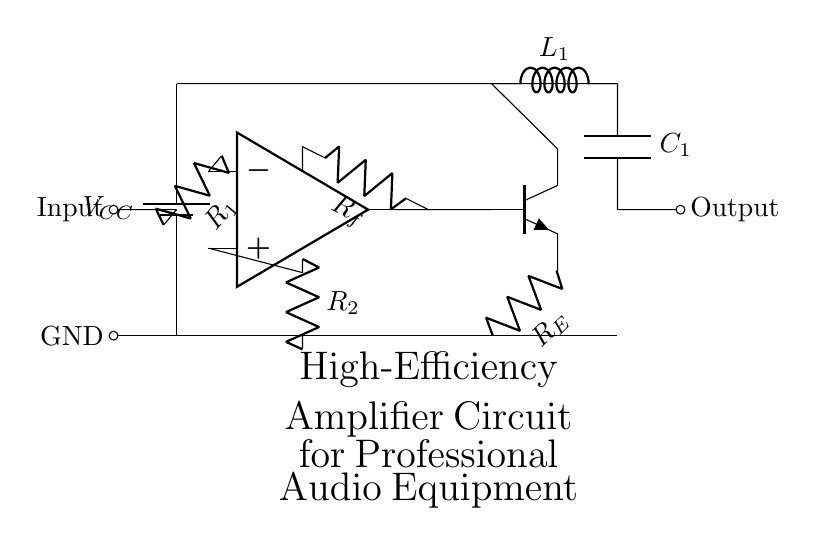What is the power supply voltage? The power supply voltage is indicated as VCC, which is connected to the battery in the circuit.
Answer: VCC What component is used for input in the circuit? The component used for input in the circuit is a resistor labeled R1, connected to the inverting input of the operational amplifier.
Answer: R1 How many resistors are present in the circuit? There are three resistors in the circuit: R1, R2, and RF.
Answer: Three Which type of transistor is employed in the output stage? The transistor used in the output stage is an NPN transistor, denoted as Q1, which is indicated in the circuit by the npn label.
Answer: NPN What is the purpose of the feedback network in this circuit? The feedback network, composed of resistor RF, stabilizes the gain of the amplifier by providing a portion of the output signal back to the inverting input.
Answer: Stabilizes gain What is the output connection type for this amplifier? The output connection is shown as a signal connection, which is labeled as Output, indicating the amplifying function of the circuit.
Answer: Output What components are used for filtering in the output stage? The output stage includes an inductor L1 and a capacitor C1, which together serve to filter the output signal.
Answer: L1 and C1 